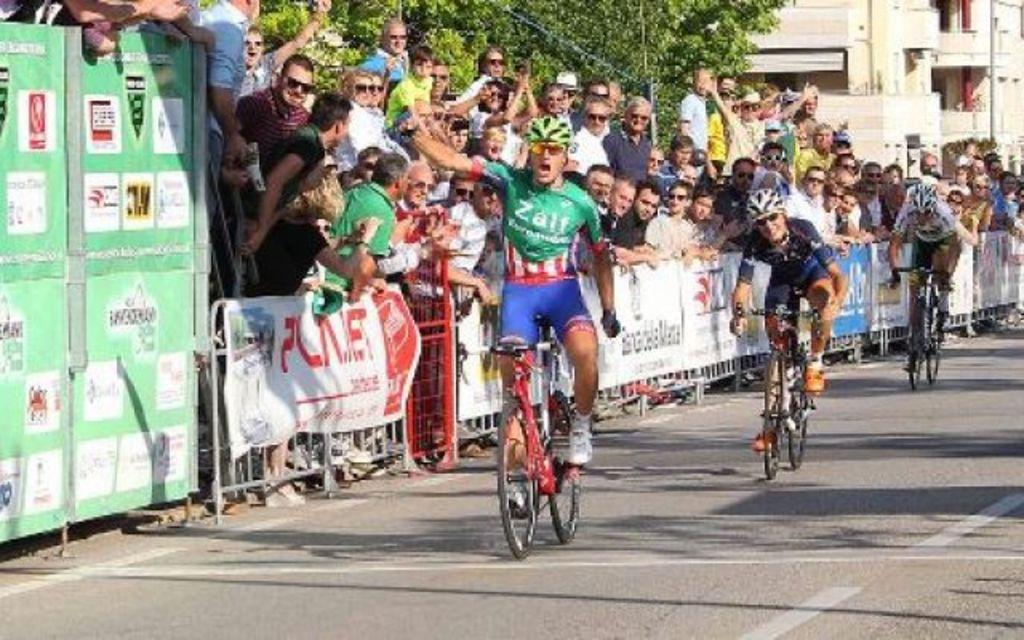<image>
Give a short and clear explanation of the subsequent image. A man riding a bike in a race wearing a green shirt that says ZALF. 